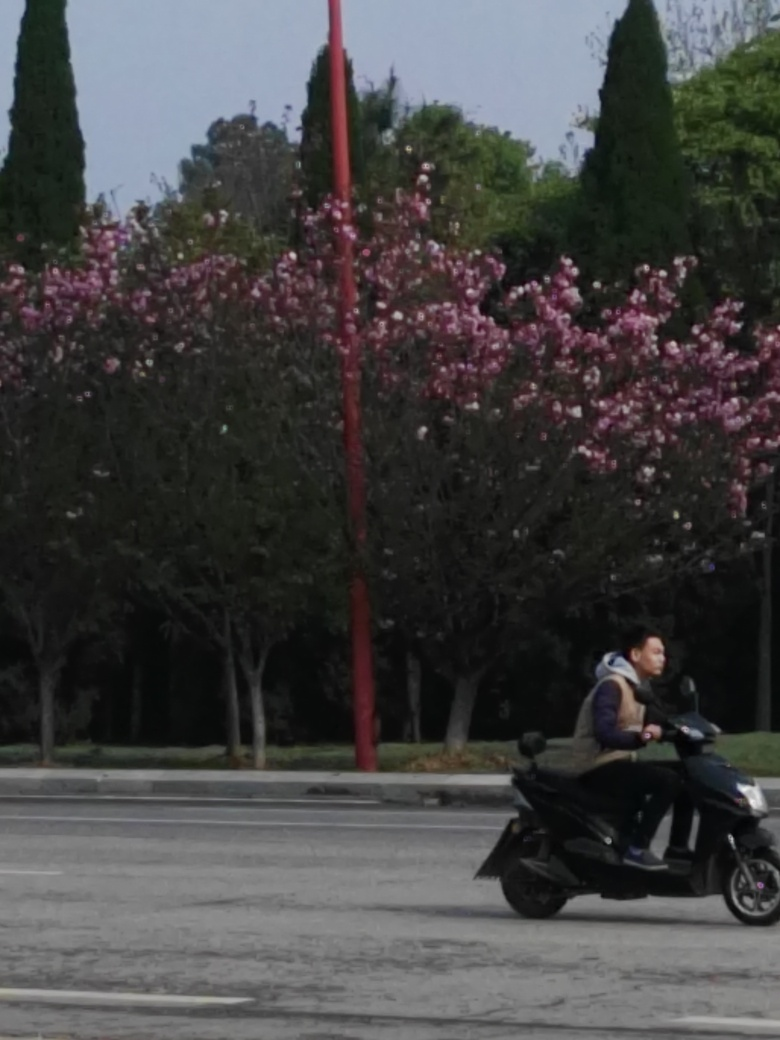What is the significance of the red pole in the image? The red pole serves as a strong visual element due to its vibrant color, which immediately draws the viewer's attention amidst the more muted tones of the surroundings. While its specific purpose is not clear from the image, it could be a part of street signage, a light pole, or a decorative item intended to add aesthetic contrast or guide traffic. 